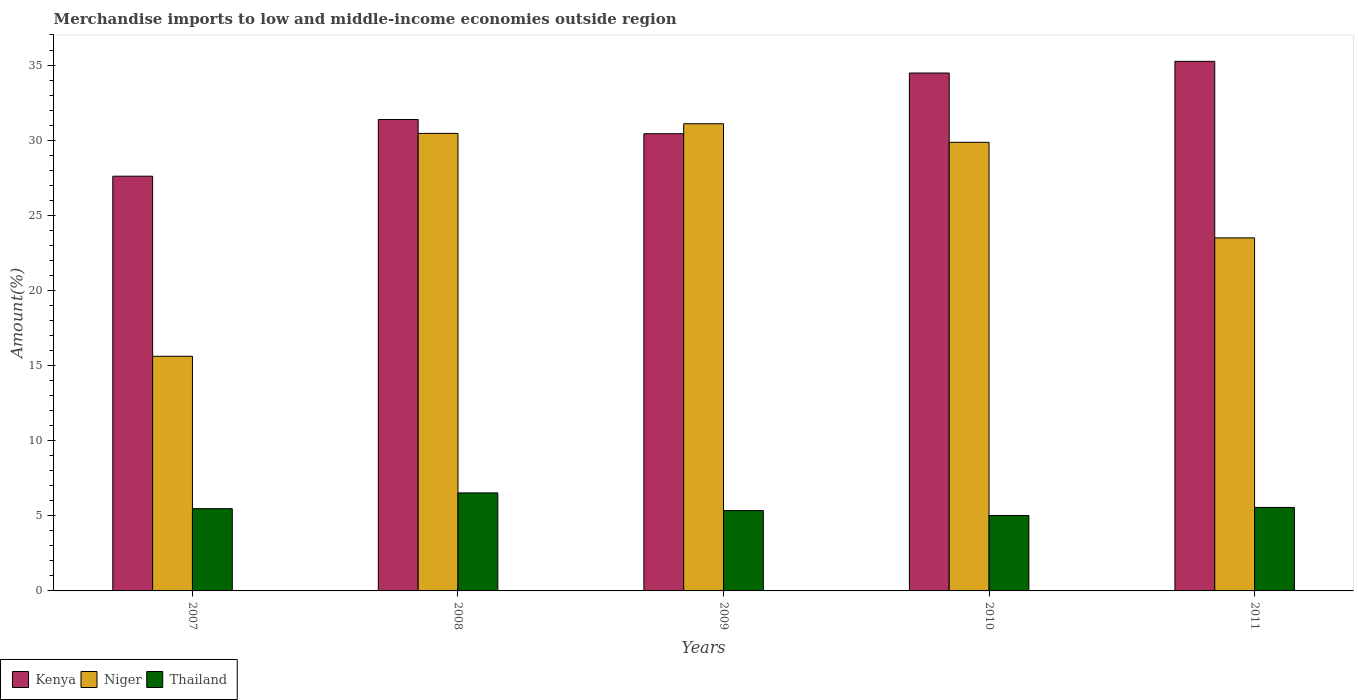What is the percentage of amount earned from merchandise imports in Kenya in 2010?
Your answer should be compact. 34.47. Across all years, what is the maximum percentage of amount earned from merchandise imports in Thailand?
Give a very brief answer. 6.52. Across all years, what is the minimum percentage of amount earned from merchandise imports in Niger?
Give a very brief answer. 15.62. In which year was the percentage of amount earned from merchandise imports in Kenya minimum?
Provide a short and direct response. 2007. What is the total percentage of amount earned from merchandise imports in Niger in the graph?
Ensure brevity in your answer.  130.52. What is the difference between the percentage of amount earned from merchandise imports in Kenya in 2007 and that in 2011?
Your answer should be compact. -7.64. What is the difference between the percentage of amount earned from merchandise imports in Thailand in 2008 and the percentage of amount earned from merchandise imports in Kenya in 2011?
Offer a terse response. -28.72. What is the average percentage of amount earned from merchandise imports in Kenya per year?
Offer a terse response. 31.82. In the year 2010, what is the difference between the percentage of amount earned from merchandise imports in Thailand and percentage of amount earned from merchandise imports in Niger?
Offer a terse response. -24.84. In how many years, is the percentage of amount earned from merchandise imports in Kenya greater than 10 %?
Your answer should be very brief. 5. What is the ratio of the percentage of amount earned from merchandise imports in Niger in 2010 to that in 2011?
Make the answer very short. 1.27. Is the percentage of amount earned from merchandise imports in Thailand in 2008 less than that in 2009?
Your answer should be very brief. No. What is the difference between the highest and the second highest percentage of amount earned from merchandise imports in Kenya?
Provide a succinct answer. 0.78. What is the difference between the highest and the lowest percentage of amount earned from merchandise imports in Kenya?
Give a very brief answer. 7.64. In how many years, is the percentage of amount earned from merchandise imports in Kenya greater than the average percentage of amount earned from merchandise imports in Kenya taken over all years?
Offer a terse response. 2. Is the sum of the percentage of amount earned from merchandise imports in Thailand in 2009 and 2011 greater than the maximum percentage of amount earned from merchandise imports in Kenya across all years?
Your answer should be compact. No. What does the 3rd bar from the left in 2008 represents?
Offer a very short reply. Thailand. What does the 1st bar from the right in 2010 represents?
Offer a terse response. Thailand. Are all the bars in the graph horizontal?
Your response must be concise. No. How many years are there in the graph?
Your response must be concise. 5. What is the difference between two consecutive major ticks on the Y-axis?
Keep it short and to the point. 5. Are the values on the major ticks of Y-axis written in scientific E-notation?
Keep it short and to the point. No. Does the graph contain any zero values?
Offer a very short reply. No. Does the graph contain grids?
Give a very brief answer. No. How many legend labels are there?
Give a very brief answer. 3. How are the legend labels stacked?
Your response must be concise. Horizontal. What is the title of the graph?
Ensure brevity in your answer.  Merchandise imports to low and middle-income economies outside region. What is the label or title of the Y-axis?
Your response must be concise. Amount(%). What is the Amount(%) in Kenya in 2007?
Your answer should be compact. 27.6. What is the Amount(%) in Niger in 2007?
Ensure brevity in your answer.  15.62. What is the Amount(%) in Thailand in 2007?
Your answer should be very brief. 5.48. What is the Amount(%) of Kenya in 2008?
Ensure brevity in your answer.  31.38. What is the Amount(%) of Niger in 2008?
Offer a terse response. 30.45. What is the Amount(%) of Thailand in 2008?
Provide a short and direct response. 6.52. What is the Amount(%) of Kenya in 2009?
Ensure brevity in your answer.  30.43. What is the Amount(%) in Niger in 2009?
Offer a terse response. 31.09. What is the Amount(%) of Thailand in 2009?
Your answer should be compact. 5.35. What is the Amount(%) in Kenya in 2010?
Ensure brevity in your answer.  34.47. What is the Amount(%) of Niger in 2010?
Provide a succinct answer. 29.86. What is the Amount(%) in Thailand in 2010?
Keep it short and to the point. 5.02. What is the Amount(%) in Kenya in 2011?
Your response must be concise. 35.25. What is the Amount(%) in Niger in 2011?
Provide a short and direct response. 23.5. What is the Amount(%) in Thailand in 2011?
Provide a short and direct response. 5.56. Across all years, what is the maximum Amount(%) of Kenya?
Offer a very short reply. 35.25. Across all years, what is the maximum Amount(%) of Niger?
Your answer should be very brief. 31.09. Across all years, what is the maximum Amount(%) in Thailand?
Give a very brief answer. 6.52. Across all years, what is the minimum Amount(%) of Kenya?
Give a very brief answer. 27.6. Across all years, what is the minimum Amount(%) in Niger?
Offer a very short reply. 15.62. Across all years, what is the minimum Amount(%) of Thailand?
Make the answer very short. 5.02. What is the total Amount(%) of Kenya in the graph?
Your answer should be compact. 159.12. What is the total Amount(%) of Niger in the graph?
Provide a short and direct response. 130.52. What is the total Amount(%) of Thailand in the graph?
Give a very brief answer. 27.92. What is the difference between the Amount(%) in Kenya in 2007 and that in 2008?
Keep it short and to the point. -3.78. What is the difference between the Amount(%) in Niger in 2007 and that in 2008?
Keep it short and to the point. -14.83. What is the difference between the Amount(%) of Thailand in 2007 and that in 2008?
Your answer should be very brief. -1.05. What is the difference between the Amount(%) in Kenya in 2007 and that in 2009?
Offer a terse response. -2.83. What is the difference between the Amount(%) in Niger in 2007 and that in 2009?
Give a very brief answer. -15.48. What is the difference between the Amount(%) in Thailand in 2007 and that in 2009?
Ensure brevity in your answer.  0.13. What is the difference between the Amount(%) in Kenya in 2007 and that in 2010?
Offer a very short reply. -6.87. What is the difference between the Amount(%) in Niger in 2007 and that in 2010?
Your response must be concise. -14.24. What is the difference between the Amount(%) of Thailand in 2007 and that in 2010?
Your response must be concise. 0.46. What is the difference between the Amount(%) in Kenya in 2007 and that in 2011?
Your response must be concise. -7.64. What is the difference between the Amount(%) in Niger in 2007 and that in 2011?
Your response must be concise. -7.88. What is the difference between the Amount(%) in Thailand in 2007 and that in 2011?
Provide a short and direct response. -0.08. What is the difference between the Amount(%) of Kenya in 2008 and that in 2009?
Your answer should be compact. 0.95. What is the difference between the Amount(%) of Niger in 2008 and that in 2009?
Keep it short and to the point. -0.64. What is the difference between the Amount(%) in Thailand in 2008 and that in 2009?
Keep it short and to the point. 1.18. What is the difference between the Amount(%) in Kenya in 2008 and that in 2010?
Provide a short and direct response. -3.09. What is the difference between the Amount(%) of Niger in 2008 and that in 2010?
Your answer should be compact. 0.59. What is the difference between the Amount(%) in Thailand in 2008 and that in 2010?
Give a very brief answer. 1.5. What is the difference between the Amount(%) in Kenya in 2008 and that in 2011?
Your answer should be compact. -3.87. What is the difference between the Amount(%) in Niger in 2008 and that in 2011?
Offer a terse response. 6.95. What is the difference between the Amount(%) of Thailand in 2008 and that in 2011?
Offer a very short reply. 0.97. What is the difference between the Amount(%) of Kenya in 2009 and that in 2010?
Offer a terse response. -4.04. What is the difference between the Amount(%) in Niger in 2009 and that in 2010?
Offer a terse response. 1.24. What is the difference between the Amount(%) of Thailand in 2009 and that in 2010?
Provide a short and direct response. 0.33. What is the difference between the Amount(%) in Kenya in 2009 and that in 2011?
Give a very brief answer. -4.82. What is the difference between the Amount(%) of Niger in 2009 and that in 2011?
Your answer should be very brief. 7.6. What is the difference between the Amount(%) in Thailand in 2009 and that in 2011?
Keep it short and to the point. -0.21. What is the difference between the Amount(%) in Kenya in 2010 and that in 2011?
Give a very brief answer. -0.78. What is the difference between the Amount(%) of Niger in 2010 and that in 2011?
Offer a very short reply. 6.36. What is the difference between the Amount(%) of Thailand in 2010 and that in 2011?
Offer a terse response. -0.54. What is the difference between the Amount(%) of Kenya in 2007 and the Amount(%) of Niger in 2008?
Your answer should be compact. -2.85. What is the difference between the Amount(%) of Kenya in 2007 and the Amount(%) of Thailand in 2008?
Offer a terse response. 21.08. What is the difference between the Amount(%) of Niger in 2007 and the Amount(%) of Thailand in 2008?
Your answer should be compact. 9.09. What is the difference between the Amount(%) in Kenya in 2007 and the Amount(%) in Niger in 2009?
Provide a succinct answer. -3.49. What is the difference between the Amount(%) in Kenya in 2007 and the Amount(%) in Thailand in 2009?
Your answer should be compact. 22.26. What is the difference between the Amount(%) in Niger in 2007 and the Amount(%) in Thailand in 2009?
Your answer should be compact. 10.27. What is the difference between the Amount(%) of Kenya in 2007 and the Amount(%) of Niger in 2010?
Provide a succinct answer. -2.26. What is the difference between the Amount(%) in Kenya in 2007 and the Amount(%) in Thailand in 2010?
Give a very brief answer. 22.58. What is the difference between the Amount(%) in Niger in 2007 and the Amount(%) in Thailand in 2010?
Your answer should be very brief. 10.6. What is the difference between the Amount(%) in Kenya in 2007 and the Amount(%) in Niger in 2011?
Offer a terse response. 4.11. What is the difference between the Amount(%) in Kenya in 2007 and the Amount(%) in Thailand in 2011?
Provide a succinct answer. 22.05. What is the difference between the Amount(%) in Niger in 2007 and the Amount(%) in Thailand in 2011?
Keep it short and to the point. 10.06. What is the difference between the Amount(%) in Kenya in 2008 and the Amount(%) in Niger in 2009?
Offer a very short reply. 0.28. What is the difference between the Amount(%) of Kenya in 2008 and the Amount(%) of Thailand in 2009?
Ensure brevity in your answer.  26.03. What is the difference between the Amount(%) in Niger in 2008 and the Amount(%) in Thailand in 2009?
Ensure brevity in your answer.  25.1. What is the difference between the Amount(%) of Kenya in 2008 and the Amount(%) of Niger in 2010?
Provide a succinct answer. 1.52. What is the difference between the Amount(%) in Kenya in 2008 and the Amount(%) in Thailand in 2010?
Your answer should be very brief. 26.36. What is the difference between the Amount(%) in Niger in 2008 and the Amount(%) in Thailand in 2010?
Give a very brief answer. 25.43. What is the difference between the Amount(%) in Kenya in 2008 and the Amount(%) in Niger in 2011?
Your answer should be very brief. 7.88. What is the difference between the Amount(%) of Kenya in 2008 and the Amount(%) of Thailand in 2011?
Your response must be concise. 25.82. What is the difference between the Amount(%) of Niger in 2008 and the Amount(%) of Thailand in 2011?
Keep it short and to the point. 24.89. What is the difference between the Amount(%) of Kenya in 2009 and the Amount(%) of Niger in 2010?
Provide a short and direct response. 0.57. What is the difference between the Amount(%) of Kenya in 2009 and the Amount(%) of Thailand in 2010?
Offer a very short reply. 25.41. What is the difference between the Amount(%) of Niger in 2009 and the Amount(%) of Thailand in 2010?
Ensure brevity in your answer.  26.07. What is the difference between the Amount(%) of Kenya in 2009 and the Amount(%) of Niger in 2011?
Ensure brevity in your answer.  6.93. What is the difference between the Amount(%) in Kenya in 2009 and the Amount(%) in Thailand in 2011?
Give a very brief answer. 24.87. What is the difference between the Amount(%) of Niger in 2009 and the Amount(%) of Thailand in 2011?
Keep it short and to the point. 25.54. What is the difference between the Amount(%) of Kenya in 2010 and the Amount(%) of Niger in 2011?
Give a very brief answer. 10.97. What is the difference between the Amount(%) of Kenya in 2010 and the Amount(%) of Thailand in 2011?
Offer a terse response. 28.91. What is the difference between the Amount(%) of Niger in 2010 and the Amount(%) of Thailand in 2011?
Your answer should be very brief. 24.3. What is the average Amount(%) of Kenya per year?
Keep it short and to the point. 31.82. What is the average Amount(%) of Niger per year?
Keep it short and to the point. 26.1. What is the average Amount(%) of Thailand per year?
Give a very brief answer. 5.58. In the year 2007, what is the difference between the Amount(%) of Kenya and Amount(%) of Niger?
Provide a short and direct response. 11.99. In the year 2007, what is the difference between the Amount(%) in Kenya and Amount(%) in Thailand?
Give a very brief answer. 22.13. In the year 2007, what is the difference between the Amount(%) in Niger and Amount(%) in Thailand?
Offer a terse response. 10.14. In the year 2008, what is the difference between the Amount(%) of Kenya and Amount(%) of Niger?
Your answer should be very brief. 0.93. In the year 2008, what is the difference between the Amount(%) in Kenya and Amount(%) in Thailand?
Make the answer very short. 24.85. In the year 2008, what is the difference between the Amount(%) of Niger and Amount(%) of Thailand?
Provide a succinct answer. 23.93. In the year 2009, what is the difference between the Amount(%) in Kenya and Amount(%) in Niger?
Give a very brief answer. -0.67. In the year 2009, what is the difference between the Amount(%) of Kenya and Amount(%) of Thailand?
Your answer should be compact. 25.08. In the year 2009, what is the difference between the Amount(%) of Niger and Amount(%) of Thailand?
Your answer should be very brief. 25.75. In the year 2010, what is the difference between the Amount(%) of Kenya and Amount(%) of Niger?
Offer a very short reply. 4.61. In the year 2010, what is the difference between the Amount(%) of Kenya and Amount(%) of Thailand?
Your response must be concise. 29.45. In the year 2010, what is the difference between the Amount(%) in Niger and Amount(%) in Thailand?
Give a very brief answer. 24.84. In the year 2011, what is the difference between the Amount(%) of Kenya and Amount(%) of Niger?
Keep it short and to the point. 11.75. In the year 2011, what is the difference between the Amount(%) of Kenya and Amount(%) of Thailand?
Make the answer very short. 29.69. In the year 2011, what is the difference between the Amount(%) of Niger and Amount(%) of Thailand?
Give a very brief answer. 17.94. What is the ratio of the Amount(%) of Kenya in 2007 to that in 2008?
Your answer should be very brief. 0.88. What is the ratio of the Amount(%) of Niger in 2007 to that in 2008?
Your answer should be very brief. 0.51. What is the ratio of the Amount(%) of Thailand in 2007 to that in 2008?
Provide a short and direct response. 0.84. What is the ratio of the Amount(%) in Kenya in 2007 to that in 2009?
Make the answer very short. 0.91. What is the ratio of the Amount(%) of Niger in 2007 to that in 2009?
Your answer should be compact. 0.5. What is the ratio of the Amount(%) of Kenya in 2007 to that in 2010?
Keep it short and to the point. 0.8. What is the ratio of the Amount(%) of Niger in 2007 to that in 2010?
Offer a terse response. 0.52. What is the ratio of the Amount(%) of Thailand in 2007 to that in 2010?
Your answer should be compact. 1.09. What is the ratio of the Amount(%) of Kenya in 2007 to that in 2011?
Offer a very short reply. 0.78. What is the ratio of the Amount(%) of Niger in 2007 to that in 2011?
Ensure brevity in your answer.  0.66. What is the ratio of the Amount(%) of Kenya in 2008 to that in 2009?
Your answer should be very brief. 1.03. What is the ratio of the Amount(%) in Niger in 2008 to that in 2009?
Offer a terse response. 0.98. What is the ratio of the Amount(%) in Thailand in 2008 to that in 2009?
Your answer should be compact. 1.22. What is the ratio of the Amount(%) of Kenya in 2008 to that in 2010?
Give a very brief answer. 0.91. What is the ratio of the Amount(%) in Niger in 2008 to that in 2010?
Provide a short and direct response. 1.02. What is the ratio of the Amount(%) in Thailand in 2008 to that in 2010?
Ensure brevity in your answer.  1.3. What is the ratio of the Amount(%) in Kenya in 2008 to that in 2011?
Provide a succinct answer. 0.89. What is the ratio of the Amount(%) in Niger in 2008 to that in 2011?
Provide a succinct answer. 1.3. What is the ratio of the Amount(%) in Thailand in 2008 to that in 2011?
Offer a terse response. 1.17. What is the ratio of the Amount(%) of Kenya in 2009 to that in 2010?
Give a very brief answer. 0.88. What is the ratio of the Amount(%) of Niger in 2009 to that in 2010?
Give a very brief answer. 1.04. What is the ratio of the Amount(%) of Thailand in 2009 to that in 2010?
Your answer should be compact. 1.07. What is the ratio of the Amount(%) in Kenya in 2009 to that in 2011?
Make the answer very short. 0.86. What is the ratio of the Amount(%) of Niger in 2009 to that in 2011?
Your response must be concise. 1.32. What is the ratio of the Amount(%) in Thailand in 2009 to that in 2011?
Keep it short and to the point. 0.96. What is the ratio of the Amount(%) of Kenya in 2010 to that in 2011?
Provide a short and direct response. 0.98. What is the ratio of the Amount(%) of Niger in 2010 to that in 2011?
Ensure brevity in your answer.  1.27. What is the ratio of the Amount(%) in Thailand in 2010 to that in 2011?
Your response must be concise. 0.9. What is the difference between the highest and the second highest Amount(%) of Kenya?
Offer a very short reply. 0.78. What is the difference between the highest and the second highest Amount(%) in Niger?
Offer a terse response. 0.64. What is the difference between the highest and the second highest Amount(%) in Thailand?
Ensure brevity in your answer.  0.97. What is the difference between the highest and the lowest Amount(%) of Kenya?
Offer a very short reply. 7.64. What is the difference between the highest and the lowest Amount(%) of Niger?
Give a very brief answer. 15.48. What is the difference between the highest and the lowest Amount(%) in Thailand?
Keep it short and to the point. 1.5. 